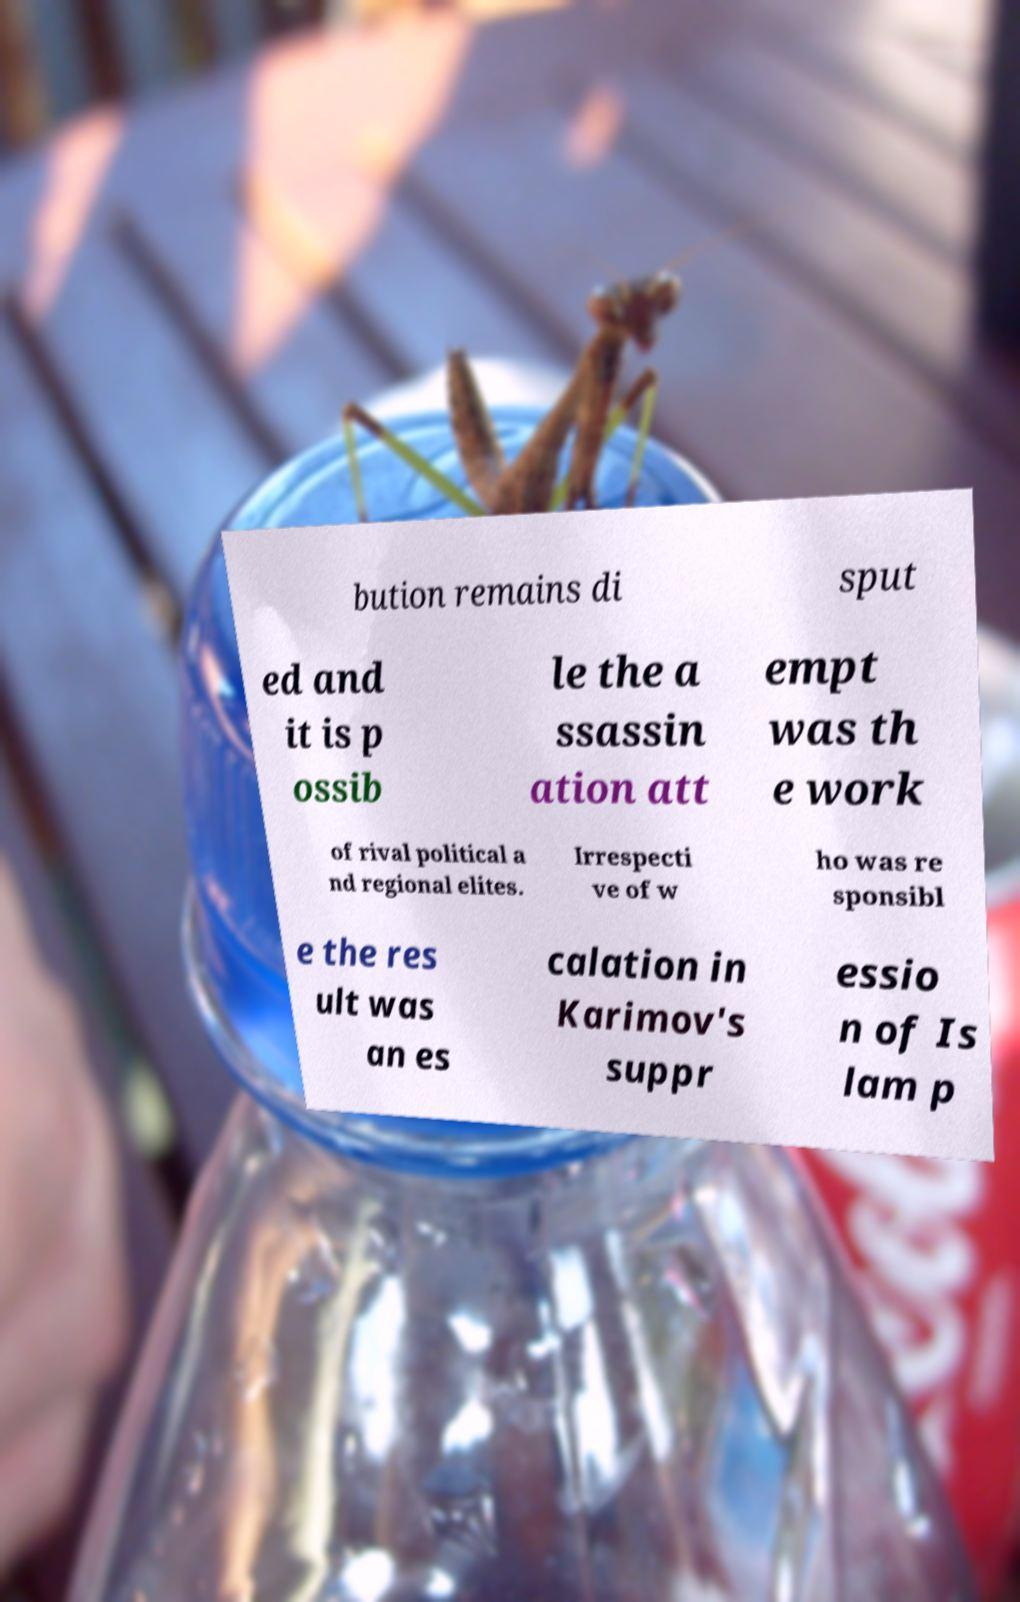Please identify and transcribe the text found in this image. bution remains di sput ed and it is p ossib le the a ssassin ation att empt was th e work of rival political a nd regional elites. Irrespecti ve of w ho was re sponsibl e the res ult was an es calation in Karimov's suppr essio n of Is lam p 